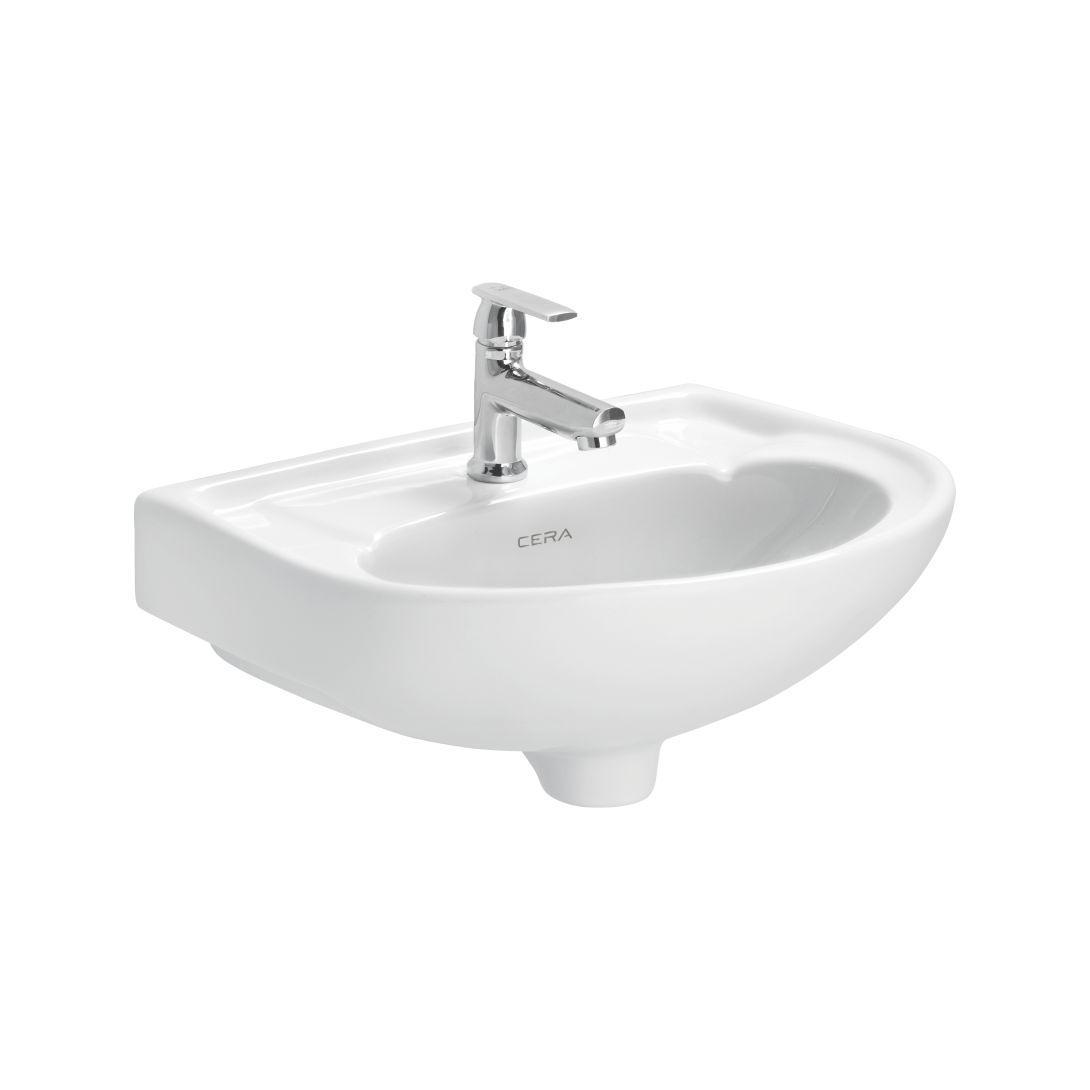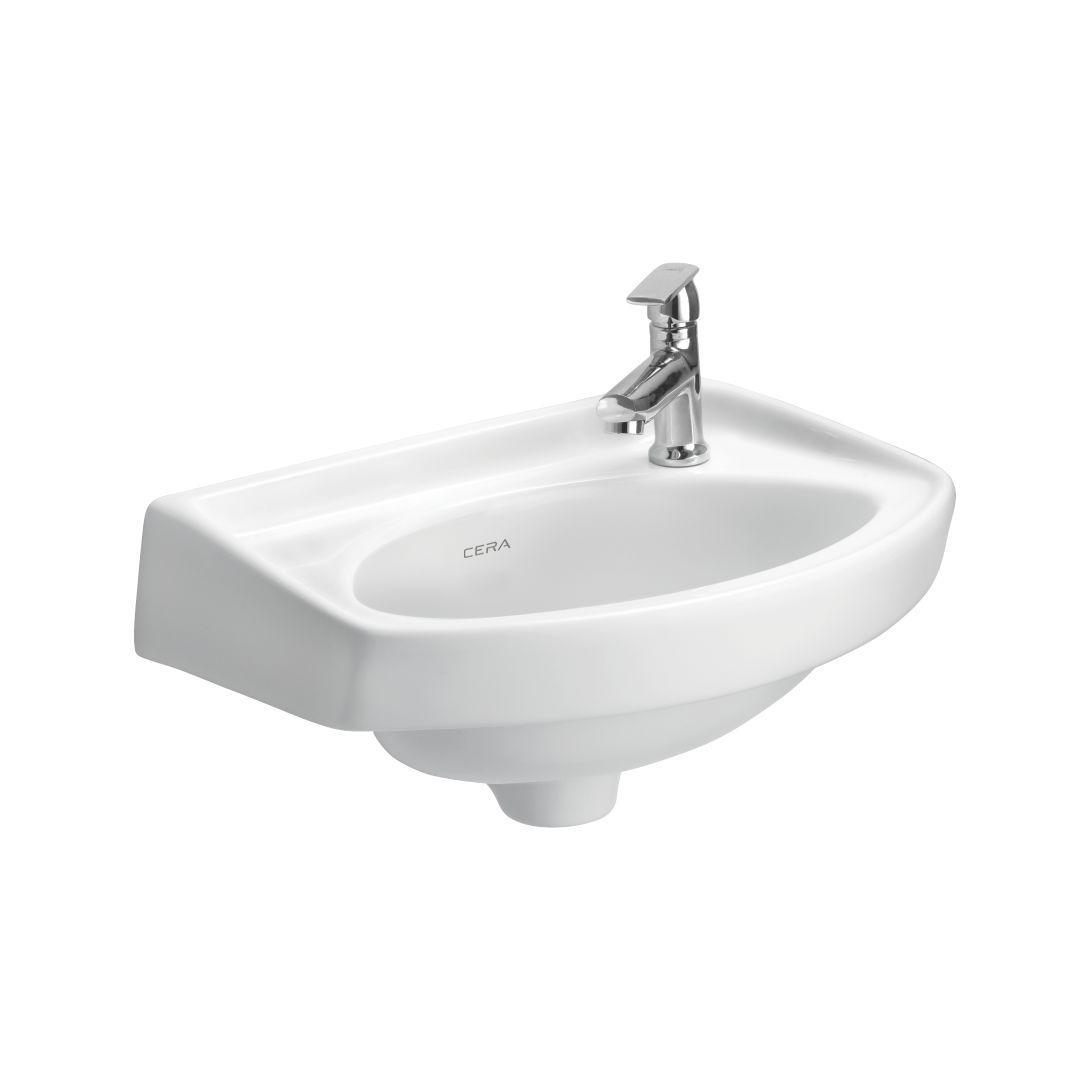The first image is the image on the left, the second image is the image on the right. Analyze the images presented: Is the assertion "Each sink has a rounded outer edge and back edge that fits parallel to a wall." valid? Answer yes or no. Yes. 